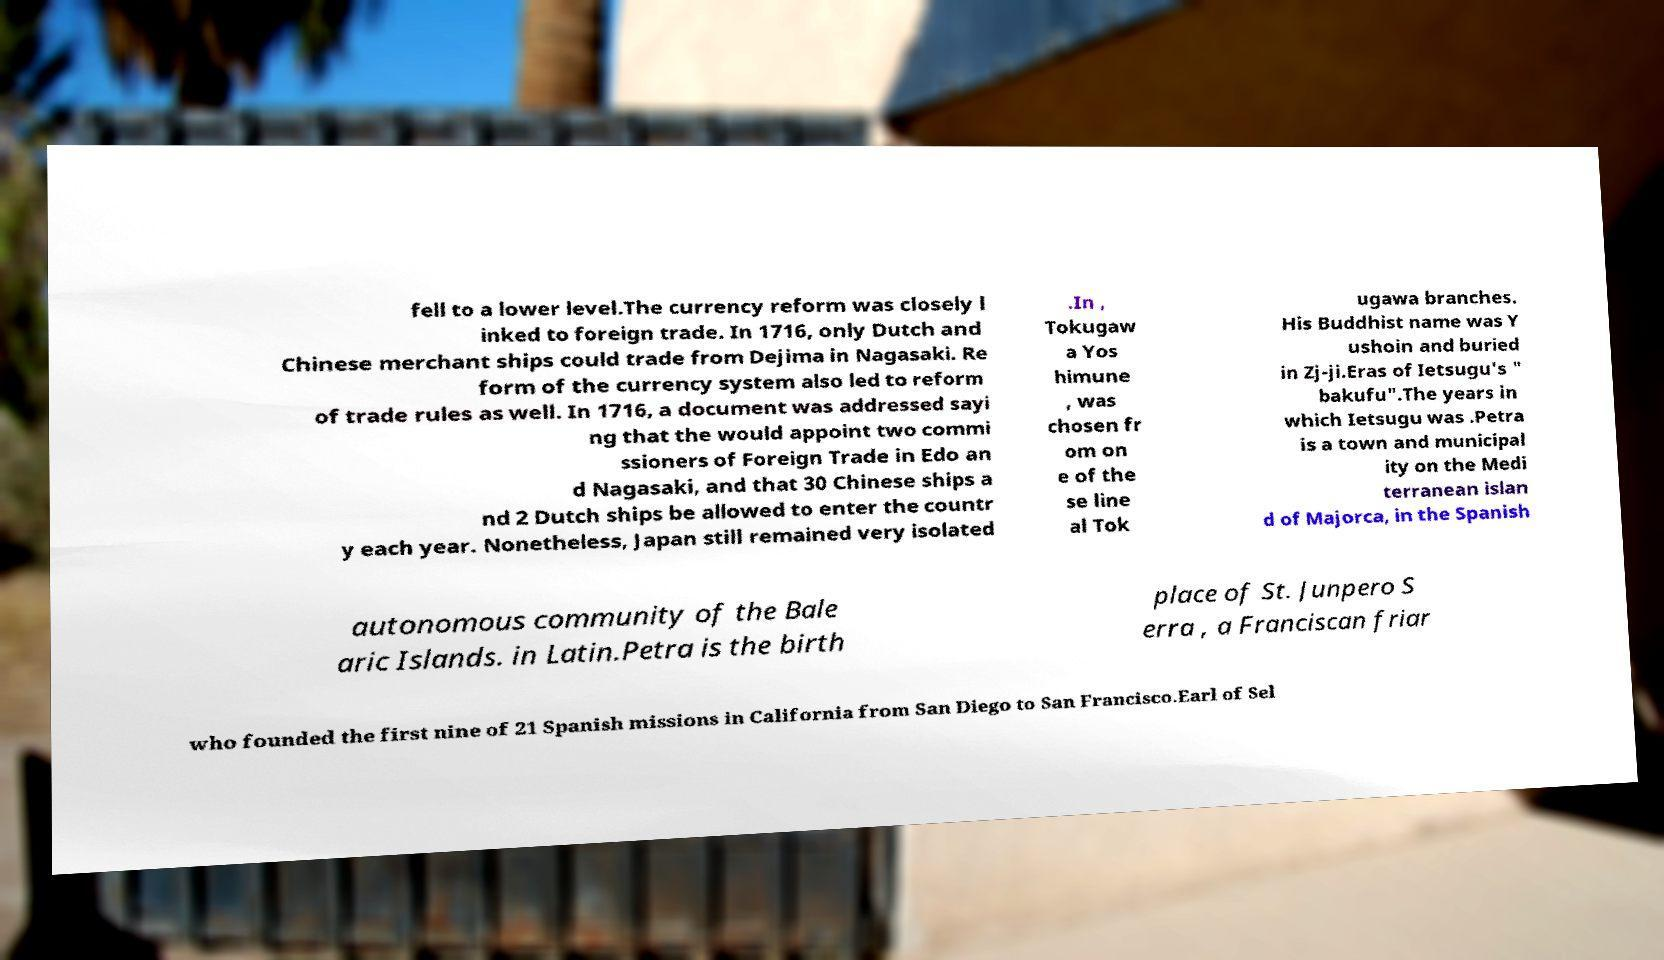Please read and relay the text visible in this image. What does it say? fell to a lower level.The currency reform was closely l inked to foreign trade. In 1716, only Dutch and Chinese merchant ships could trade from Dejima in Nagasaki. Re form of the currency system also led to reform of trade rules as well. In 1716, a document was addressed sayi ng that the would appoint two commi ssioners of Foreign Trade in Edo an d Nagasaki, and that 30 Chinese ships a nd 2 Dutch ships be allowed to enter the countr y each year. Nonetheless, Japan still remained very isolated .In , Tokugaw a Yos himune , was chosen fr om on e of the se line al Tok ugawa branches. His Buddhist name was Y ushoin and buried in Zj-ji.Eras of Ietsugu's " bakufu".The years in which Ietsugu was .Petra is a town and municipal ity on the Medi terranean islan d of Majorca, in the Spanish autonomous community of the Bale aric Islands. in Latin.Petra is the birth place of St. Junpero S erra , a Franciscan friar who founded the first nine of 21 Spanish missions in California from San Diego to San Francisco.Earl of Sel 